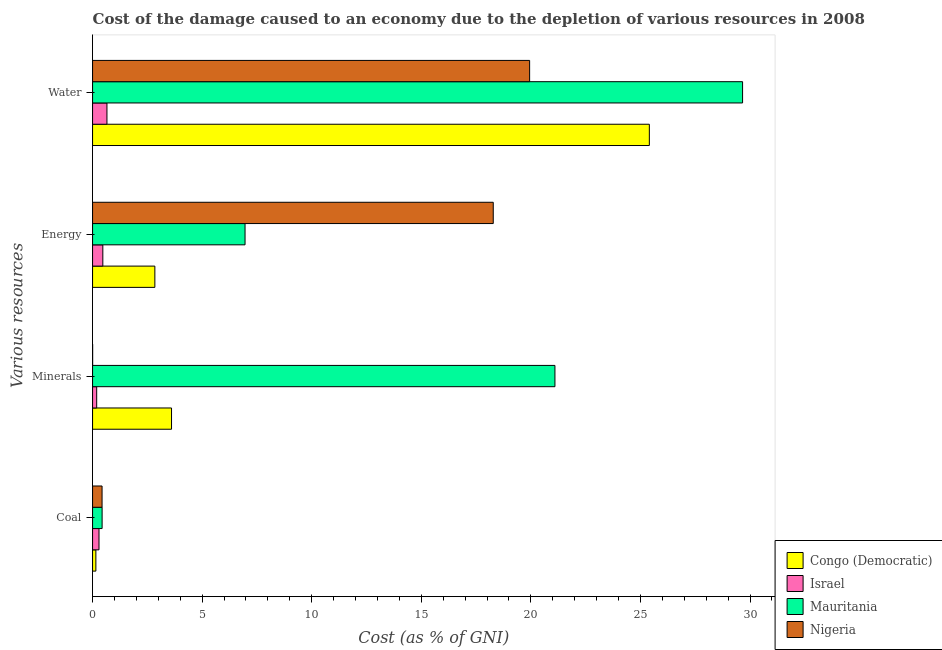How many groups of bars are there?
Offer a terse response. 4. Are the number of bars on each tick of the Y-axis equal?
Make the answer very short. Yes. How many bars are there on the 1st tick from the bottom?
Your answer should be very brief. 4. What is the label of the 3rd group of bars from the top?
Provide a short and direct response. Minerals. What is the cost of damage due to depletion of minerals in Nigeria?
Your answer should be compact. 0. Across all countries, what is the maximum cost of damage due to depletion of minerals?
Ensure brevity in your answer.  21.1. Across all countries, what is the minimum cost of damage due to depletion of coal?
Offer a very short reply. 0.15. In which country was the cost of damage due to depletion of water maximum?
Your response must be concise. Mauritania. In which country was the cost of damage due to depletion of water minimum?
Keep it short and to the point. Israel. What is the total cost of damage due to depletion of water in the graph?
Keep it short and to the point. 75.67. What is the difference between the cost of damage due to depletion of minerals in Israel and that in Nigeria?
Offer a very short reply. 0.18. What is the difference between the cost of damage due to depletion of water in Congo (Democratic) and the cost of damage due to depletion of minerals in Nigeria?
Provide a short and direct response. 25.4. What is the average cost of damage due to depletion of water per country?
Offer a very short reply. 18.92. What is the difference between the cost of damage due to depletion of water and cost of damage due to depletion of energy in Congo (Democratic)?
Give a very brief answer. 22.56. In how many countries, is the cost of damage due to depletion of energy greater than 22 %?
Provide a succinct answer. 0. What is the ratio of the cost of damage due to depletion of minerals in Mauritania to that in Nigeria?
Give a very brief answer. 6323.89. Is the cost of damage due to depletion of energy in Nigeria less than that in Congo (Democratic)?
Make the answer very short. No. Is the difference between the cost of damage due to depletion of coal in Israel and Nigeria greater than the difference between the cost of damage due to depletion of minerals in Israel and Nigeria?
Your answer should be compact. No. What is the difference between the highest and the second highest cost of damage due to depletion of water?
Offer a terse response. 4.25. What is the difference between the highest and the lowest cost of damage due to depletion of coal?
Offer a terse response. 0.28. In how many countries, is the cost of damage due to depletion of water greater than the average cost of damage due to depletion of water taken over all countries?
Your answer should be very brief. 3. Is the sum of the cost of damage due to depletion of water in Mauritania and Nigeria greater than the maximum cost of damage due to depletion of minerals across all countries?
Make the answer very short. Yes. Is it the case that in every country, the sum of the cost of damage due to depletion of water and cost of damage due to depletion of coal is greater than the sum of cost of damage due to depletion of minerals and cost of damage due to depletion of energy?
Offer a very short reply. Yes. What does the 1st bar from the top in Coal represents?
Make the answer very short. Nigeria. What does the 1st bar from the bottom in Energy represents?
Give a very brief answer. Congo (Democratic). How many bars are there?
Provide a succinct answer. 16. Are all the bars in the graph horizontal?
Provide a short and direct response. Yes. What is the difference between two consecutive major ticks on the X-axis?
Your response must be concise. 5. Are the values on the major ticks of X-axis written in scientific E-notation?
Keep it short and to the point. No. Does the graph contain any zero values?
Give a very brief answer. No. Does the graph contain grids?
Your answer should be compact. No. How are the legend labels stacked?
Your answer should be compact. Vertical. What is the title of the graph?
Offer a terse response. Cost of the damage caused to an economy due to the depletion of various resources in 2008 . What is the label or title of the X-axis?
Provide a short and direct response. Cost (as % of GNI). What is the label or title of the Y-axis?
Provide a short and direct response. Various resources. What is the Cost (as % of GNI) of Congo (Democratic) in Coal?
Offer a terse response. 0.15. What is the Cost (as % of GNI) in Israel in Coal?
Your response must be concise. 0.29. What is the Cost (as % of GNI) of Mauritania in Coal?
Your answer should be compact. 0.44. What is the Cost (as % of GNI) in Nigeria in Coal?
Ensure brevity in your answer.  0.43. What is the Cost (as % of GNI) in Congo (Democratic) in Minerals?
Make the answer very short. 3.6. What is the Cost (as % of GNI) of Israel in Minerals?
Your answer should be compact. 0.19. What is the Cost (as % of GNI) in Mauritania in Minerals?
Make the answer very short. 21.1. What is the Cost (as % of GNI) in Nigeria in Minerals?
Keep it short and to the point. 0. What is the Cost (as % of GNI) in Congo (Democratic) in Energy?
Give a very brief answer. 2.84. What is the Cost (as % of GNI) in Israel in Energy?
Provide a succinct answer. 0.47. What is the Cost (as % of GNI) in Mauritania in Energy?
Provide a succinct answer. 6.96. What is the Cost (as % of GNI) of Nigeria in Energy?
Keep it short and to the point. 18.28. What is the Cost (as % of GNI) of Congo (Democratic) in Water?
Offer a terse response. 25.41. What is the Cost (as % of GNI) of Israel in Water?
Your answer should be very brief. 0.66. What is the Cost (as % of GNI) of Mauritania in Water?
Give a very brief answer. 29.66. What is the Cost (as % of GNI) of Nigeria in Water?
Ensure brevity in your answer.  19.94. Across all Various resources, what is the maximum Cost (as % of GNI) in Congo (Democratic)?
Give a very brief answer. 25.41. Across all Various resources, what is the maximum Cost (as % of GNI) in Israel?
Keep it short and to the point. 0.66. Across all Various resources, what is the maximum Cost (as % of GNI) in Mauritania?
Provide a short and direct response. 29.66. Across all Various resources, what is the maximum Cost (as % of GNI) of Nigeria?
Provide a succinct answer. 19.94. Across all Various resources, what is the minimum Cost (as % of GNI) of Congo (Democratic)?
Keep it short and to the point. 0.15. Across all Various resources, what is the minimum Cost (as % of GNI) in Israel?
Provide a short and direct response. 0.19. Across all Various resources, what is the minimum Cost (as % of GNI) in Mauritania?
Provide a short and direct response. 0.44. Across all Various resources, what is the minimum Cost (as % of GNI) in Nigeria?
Provide a short and direct response. 0. What is the total Cost (as % of GNI) of Congo (Democratic) in the graph?
Offer a very short reply. 32. What is the total Cost (as % of GNI) in Israel in the graph?
Your answer should be very brief. 1.61. What is the total Cost (as % of GNI) in Mauritania in the graph?
Provide a short and direct response. 58.15. What is the total Cost (as % of GNI) of Nigeria in the graph?
Your answer should be compact. 38.66. What is the difference between the Cost (as % of GNI) of Congo (Democratic) in Coal and that in Minerals?
Keep it short and to the point. -3.45. What is the difference between the Cost (as % of GNI) in Israel in Coal and that in Minerals?
Offer a terse response. 0.11. What is the difference between the Cost (as % of GNI) of Mauritania in Coal and that in Minerals?
Your response must be concise. -20.66. What is the difference between the Cost (as % of GNI) of Nigeria in Coal and that in Minerals?
Give a very brief answer. 0.43. What is the difference between the Cost (as % of GNI) in Congo (Democratic) in Coal and that in Energy?
Your response must be concise. -2.69. What is the difference between the Cost (as % of GNI) of Israel in Coal and that in Energy?
Provide a short and direct response. -0.17. What is the difference between the Cost (as % of GNI) of Mauritania in Coal and that in Energy?
Make the answer very short. -6.52. What is the difference between the Cost (as % of GNI) in Nigeria in Coal and that in Energy?
Offer a very short reply. -17.85. What is the difference between the Cost (as % of GNI) in Congo (Democratic) in Coal and that in Water?
Your answer should be very brief. -25.26. What is the difference between the Cost (as % of GNI) in Israel in Coal and that in Water?
Ensure brevity in your answer.  -0.36. What is the difference between the Cost (as % of GNI) of Mauritania in Coal and that in Water?
Your answer should be very brief. -29.23. What is the difference between the Cost (as % of GNI) in Nigeria in Coal and that in Water?
Provide a succinct answer. -19.51. What is the difference between the Cost (as % of GNI) in Congo (Democratic) in Minerals and that in Energy?
Keep it short and to the point. 0.76. What is the difference between the Cost (as % of GNI) in Israel in Minerals and that in Energy?
Make the answer very short. -0.28. What is the difference between the Cost (as % of GNI) of Mauritania in Minerals and that in Energy?
Make the answer very short. 14.14. What is the difference between the Cost (as % of GNI) of Nigeria in Minerals and that in Energy?
Your answer should be compact. -18.28. What is the difference between the Cost (as % of GNI) in Congo (Democratic) in Minerals and that in Water?
Offer a terse response. -21.8. What is the difference between the Cost (as % of GNI) in Israel in Minerals and that in Water?
Keep it short and to the point. -0.47. What is the difference between the Cost (as % of GNI) in Mauritania in Minerals and that in Water?
Your response must be concise. -8.56. What is the difference between the Cost (as % of GNI) in Nigeria in Minerals and that in Water?
Give a very brief answer. -19.94. What is the difference between the Cost (as % of GNI) of Congo (Democratic) in Energy and that in Water?
Offer a terse response. -22.56. What is the difference between the Cost (as % of GNI) of Israel in Energy and that in Water?
Make the answer very short. -0.19. What is the difference between the Cost (as % of GNI) of Mauritania in Energy and that in Water?
Your response must be concise. -22.7. What is the difference between the Cost (as % of GNI) of Nigeria in Energy and that in Water?
Your answer should be very brief. -1.66. What is the difference between the Cost (as % of GNI) in Congo (Democratic) in Coal and the Cost (as % of GNI) in Israel in Minerals?
Make the answer very short. -0.04. What is the difference between the Cost (as % of GNI) of Congo (Democratic) in Coal and the Cost (as % of GNI) of Mauritania in Minerals?
Ensure brevity in your answer.  -20.95. What is the difference between the Cost (as % of GNI) of Congo (Democratic) in Coal and the Cost (as % of GNI) of Nigeria in Minerals?
Your answer should be compact. 0.15. What is the difference between the Cost (as % of GNI) of Israel in Coal and the Cost (as % of GNI) of Mauritania in Minerals?
Provide a short and direct response. -20.81. What is the difference between the Cost (as % of GNI) of Israel in Coal and the Cost (as % of GNI) of Nigeria in Minerals?
Your answer should be compact. 0.29. What is the difference between the Cost (as % of GNI) of Mauritania in Coal and the Cost (as % of GNI) of Nigeria in Minerals?
Your answer should be compact. 0.43. What is the difference between the Cost (as % of GNI) of Congo (Democratic) in Coal and the Cost (as % of GNI) of Israel in Energy?
Provide a succinct answer. -0.32. What is the difference between the Cost (as % of GNI) in Congo (Democratic) in Coal and the Cost (as % of GNI) in Mauritania in Energy?
Keep it short and to the point. -6.81. What is the difference between the Cost (as % of GNI) of Congo (Democratic) in Coal and the Cost (as % of GNI) of Nigeria in Energy?
Make the answer very short. -18.13. What is the difference between the Cost (as % of GNI) in Israel in Coal and the Cost (as % of GNI) in Mauritania in Energy?
Make the answer very short. -6.66. What is the difference between the Cost (as % of GNI) of Israel in Coal and the Cost (as % of GNI) of Nigeria in Energy?
Offer a terse response. -17.99. What is the difference between the Cost (as % of GNI) in Mauritania in Coal and the Cost (as % of GNI) in Nigeria in Energy?
Your response must be concise. -17.85. What is the difference between the Cost (as % of GNI) in Congo (Democratic) in Coal and the Cost (as % of GNI) in Israel in Water?
Offer a terse response. -0.51. What is the difference between the Cost (as % of GNI) of Congo (Democratic) in Coal and the Cost (as % of GNI) of Mauritania in Water?
Your answer should be compact. -29.51. What is the difference between the Cost (as % of GNI) in Congo (Democratic) in Coal and the Cost (as % of GNI) in Nigeria in Water?
Your answer should be compact. -19.79. What is the difference between the Cost (as % of GNI) in Israel in Coal and the Cost (as % of GNI) in Mauritania in Water?
Your response must be concise. -29.37. What is the difference between the Cost (as % of GNI) in Israel in Coal and the Cost (as % of GNI) in Nigeria in Water?
Keep it short and to the point. -19.65. What is the difference between the Cost (as % of GNI) of Mauritania in Coal and the Cost (as % of GNI) of Nigeria in Water?
Provide a short and direct response. -19.51. What is the difference between the Cost (as % of GNI) in Congo (Democratic) in Minerals and the Cost (as % of GNI) in Israel in Energy?
Offer a terse response. 3.13. What is the difference between the Cost (as % of GNI) in Congo (Democratic) in Minerals and the Cost (as % of GNI) in Mauritania in Energy?
Provide a succinct answer. -3.35. What is the difference between the Cost (as % of GNI) of Congo (Democratic) in Minerals and the Cost (as % of GNI) of Nigeria in Energy?
Your response must be concise. -14.68. What is the difference between the Cost (as % of GNI) in Israel in Minerals and the Cost (as % of GNI) in Mauritania in Energy?
Give a very brief answer. -6.77. What is the difference between the Cost (as % of GNI) of Israel in Minerals and the Cost (as % of GNI) of Nigeria in Energy?
Your response must be concise. -18.1. What is the difference between the Cost (as % of GNI) in Mauritania in Minerals and the Cost (as % of GNI) in Nigeria in Energy?
Offer a terse response. 2.81. What is the difference between the Cost (as % of GNI) of Congo (Democratic) in Minerals and the Cost (as % of GNI) of Israel in Water?
Give a very brief answer. 2.95. What is the difference between the Cost (as % of GNI) in Congo (Democratic) in Minerals and the Cost (as % of GNI) in Mauritania in Water?
Keep it short and to the point. -26.06. What is the difference between the Cost (as % of GNI) in Congo (Democratic) in Minerals and the Cost (as % of GNI) in Nigeria in Water?
Make the answer very short. -16.34. What is the difference between the Cost (as % of GNI) in Israel in Minerals and the Cost (as % of GNI) in Mauritania in Water?
Ensure brevity in your answer.  -29.47. What is the difference between the Cost (as % of GNI) in Israel in Minerals and the Cost (as % of GNI) in Nigeria in Water?
Offer a terse response. -19.76. What is the difference between the Cost (as % of GNI) in Mauritania in Minerals and the Cost (as % of GNI) in Nigeria in Water?
Your answer should be very brief. 1.15. What is the difference between the Cost (as % of GNI) of Congo (Democratic) in Energy and the Cost (as % of GNI) of Israel in Water?
Provide a short and direct response. 2.19. What is the difference between the Cost (as % of GNI) of Congo (Democratic) in Energy and the Cost (as % of GNI) of Mauritania in Water?
Provide a short and direct response. -26.82. What is the difference between the Cost (as % of GNI) of Congo (Democratic) in Energy and the Cost (as % of GNI) of Nigeria in Water?
Your answer should be very brief. -17.1. What is the difference between the Cost (as % of GNI) in Israel in Energy and the Cost (as % of GNI) in Mauritania in Water?
Ensure brevity in your answer.  -29.19. What is the difference between the Cost (as % of GNI) of Israel in Energy and the Cost (as % of GNI) of Nigeria in Water?
Give a very brief answer. -19.48. What is the difference between the Cost (as % of GNI) in Mauritania in Energy and the Cost (as % of GNI) in Nigeria in Water?
Make the answer very short. -12.99. What is the average Cost (as % of GNI) in Congo (Democratic) per Various resources?
Your answer should be compact. 8. What is the average Cost (as % of GNI) in Israel per Various resources?
Make the answer very short. 0.4. What is the average Cost (as % of GNI) in Mauritania per Various resources?
Provide a short and direct response. 14.54. What is the average Cost (as % of GNI) of Nigeria per Various resources?
Offer a terse response. 9.67. What is the difference between the Cost (as % of GNI) in Congo (Democratic) and Cost (as % of GNI) in Israel in Coal?
Offer a terse response. -0.14. What is the difference between the Cost (as % of GNI) of Congo (Democratic) and Cost (as % of GNI) of Mauritania in Coal?
Provide a short and direct response. -0.28. What is the difference between the Cost (as % of GNI) of Congo (Democratic) and Cost (as % of GNI) of Nigeria in Coal?
Ensure brevity in your answer.  -0.28. What is the difference between the Cost (as % of GNI) of Israel and Cost (as % of GNI) of Mauritania in Coal?
Your answer should be very brief. -0.14. What is the difference between the Cost (as % of GNI) in Israel and Cost (as % of GNI) in Nigeria in Coal?
Offer a very short reply. -0.14. What is the difference between the Cost (as % of GNI) in Mauritania and Cost (as % of GNI) in Nigeria in Coal?
Your answer should be very brief. 0. What is the difference between the Cost (as % of GNI) of Congo (Democratic) and Cost (as % of GNI) of Israel in Minerals?
Provide a succinct answer. 3.41. What is the difference between the Cost (as % of GNI) of Congo (Democratic) and Cost (as % of GNI) of Mauritania in Minerals?
Your answer should be compact. -17.5. What is the difference between the Cost (as % of GNI) of Congo (Democratic) and Cost (as % of GNI) of Nigeria in Minerals?
Your answer should be very brief. 3.6. What is the difference between the Cost (as % of GNI) in Israel and Cost (as % of GNI) in Mauritania in Minerals?
Provide a short and direct response. -20.91. What is the difference between the Cost (as % of GNI) in Israel and Cost (as % of GNI) in Nigeria in Minerals?
Keep it short and to the point. 0.18. What is the difference between the Cost (as % of GNI) in Mauritania and Cost (as % of GNI) in Nigeria in Minerals?
Offer a very short reply. 21.1. What is the difference between the Cost (as % of GNI) of Congo (Democratic) and Cost (as % of GNI) of Israel in Energy?
Offer a terse response. 2.37. What is the difference between the Cost (as % of GNI) of Congo (Democratic) and Cost (as % of GNI) of Mauritania in Energy?
Make the answer very short. -4.12. What is the difference between the Cost (as % of GNI) of Congo (Democratic) and Cost (as % of GNI) of Nigeria in Energy?
Your answer should be very brief. -15.44. What is the difference between the Cost (as % of GNI) of Israel and Cost (as % of GNI) of Mauritania in Energy?
Make the answer very short. -6.49. What is the difference between the Cost (as % of GNI) of Israel and Cost (as % of GNI) of Nigeria in Energy?
Your answer should be compact. -17.82. What is the difference between the Cost (as % of GNI) in Mauritania and Cost (as % of GNI) in Nigeria in Energy?
Your response must be concise. -11.33. What is the difference between the Cost (as % of GNI) in Congo (Democratic) and Cost (as % of GNI) in Israel in Water?
Keep it short and to the point. 24.75. What is the difference between the Cost (as % of GNI) in Congo (Democratic) and Cost (as % of GNI) in Mauritania in Water?
Provide a short and direct response. -4.25. What is the difference between the Cost (as % of GNI) in Congo (Democratic) and Cost (as % of GNI) in Nigeria in Water?
Your response must be concise. 5.46. What is the difference between the Cost (as % of GNI) in Israel and Cost (as % of GNI) in Mauritania in Water?
Your answer should be very brief. -29.01. What is the difference between the Cost (as % of GNI) of Israel and Cost (as % of GNI) of Nigeria in Water?
Your response must be concise. -19.29. What is the difference between the Cost (as % of GNI) of Mauritania and Cost (as % of GNI) of Nigeria in Water?
Offer a terse response. 9.72. What is the ratio of the Cost (as % of GNI) in Congo (Democratic) in Coal to that in Minerals?
Provide a short and direct response. 0.04. What is the ratio of the Cost (as % of GNI) of Israel in Coal to that in Minerals?
Ensure brevity in your answer.  1.56. What is the ratio of the Cost (as % of GNI) in Mauritania in Coal to that in Minerals?
Provide a short and direct response. 0.02. What is the ratio of the Cost (as % of GNI) of Nigeria in Coal to that in Minerals?
Offer a very short reply. 129.95. What is the ratio of the Cost (as % of GNI) of Congo (Democratic) in Coal to that in Energy?
Keep it short and to the point. 0.05. What is the ratio of the Cost (as % of GNI) in Israel in Coal to that in Energy?
Give a very brief answer. 0.63. What is the ratio of the Cost (as % of GNI) in Mauritania in Coal to that in Energy?
Give a very brief answer. 0.06. What is the ratio of the Cost (as % of GNI) of Nigeria in Coal to that in Energy?
Your answer should be compact. 0.02. What is the ratio of the Cost (as % of GNI) in Congo (Democratic) in Coal to that in Water?
Your answer should be compact. 0.01. What is the ratio of the Cost (as % of GNI) of Israel in Coal to that in Water?
Keep it short and to the point. 0.45. What is the ratio of the Cost (as % of GNI) in Mauritania in Coal to that in Water?
Provide a succinct answer. 0.01. What is the ratio of the Cost (as % of GNI) of Nigeria in Coal to that in Water?
Offer a terse response. 0.02. What is the ratio of the Cost (as % of GNI) in Congo (Democratic) in Minerals to that in Energy?
Make the answer very short. 1.27. What is the ratio of the Cost (as % of GNI) of Israel in Minerals to that in Energy?
Provide a succinct answer. 0.4. What is the ratio of the Cost (as % of GNI) of Mauritania in Minerals to that in Energy?
Keep it short and to the point. 3.03. What is the ratio of the Cost (as % of GNI) of Nigeria in Minerals to that in Energy?
Make the answer very short. 0. What is the ratio of the Cost (as % of GNI) in Congo (Democratic) in Minerals to that in Water?
Your answer should be very brief. 0.14. What is the ratio of the Cost (as % of GNI) in Israel in Minerals to that in Water?
Your response must be concise. 0.29. What is the ratio of the Cost (as % of GNI) in Mauritania in Minerals to that in Water?
Your answer should be compact. 0.71. What is the ratio of the Cost (as % of GNI) of Congo (Democratic) in Energy to that in Water?
Give a very brief answer. 0.11. What is the ratio of the Cost (as % of GNI) in Israel in Energy to that in Water?
Offer a very short reply. 0.71. What is the ratio of the Cost (as % of GNI) in Mauritania in Energy to that in Water?
Offer a terse response. 0.23. What is the ratio of the Cost (as % of GNI) in Nigeria in Energy to that in Water?
Your response must be concise. 0.92. What is the difference between the highest and the second highest Cost (as % of GNI) in Congo (Democratic)?
Offer a terse response. 21.8. What is the difference between the highest and the second highest Cost (as % of GNI) of Israel?
Your answer should be very brief. 0.19. What is the difference between the highest and the second highest Cost (as % of GNI) of Mauritania?
Offer a terse response. 8.56. What is the difference between the highest and the second highest Cost (as % of GNI) in Nigeria?
Keep it short and to the point. 1.66. What is the difference between the highest and the lowest Cost (as % of GNI) of Congo (Democratic)?
Provide a short and direct response. 25.26. What is the difference between the highest and the lowest Cost (as % of GNI) in Israel?
Offer a very short reply. 0.47. What is the difference between the highest and the lowest Cost (as % of GNI) of Mauritania?
Your response must be concise. 29.23. What is the difference between the highest and the lowest Cost (as % of GNI) of Nigeria?
Offer a very short reply. 19.94. 